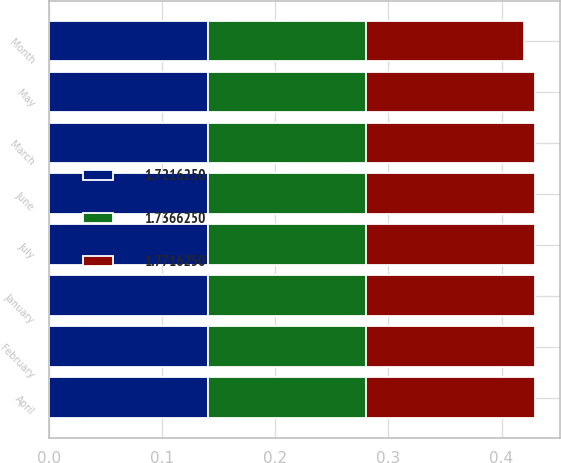Convert chart to OTSL. <chart><loc_0><loc_0><loc_500><loc_500><stacked_bar_chart><ecel><fcel>Month<fcel>January<fcel>February<fcel>March<fcel>April<fcel>May<fcel>June<fcel>July<nl><fcel>1.77163<fcel>0.14<fcel>0.15<fcel>0.15<fcel>0.15<fcel>0.15<fcel>0.15<fcel>0.15<fcel>0.15<nl><fcel>1.72162<fcel>0.14<fcel>0.14<fcel>0.14<fcel>0.14<fcel>0.14<fcel>0.14<fcel>0.14<fcel>0.14<nl><fcel>1.73663<fcel>0.14<fcel>0.14<fcel>0.14<fcel>0.14<fcel>0.14<fcel>0.14<fcel>0.14<fcel>0.14<nl></chart> 